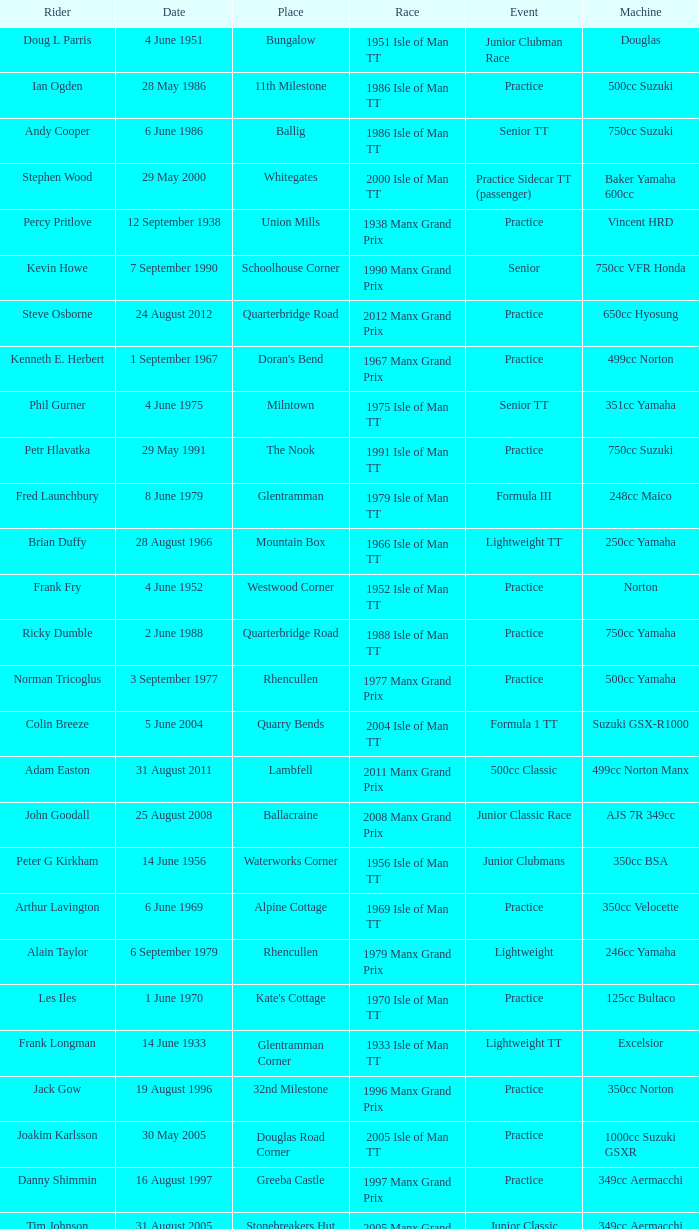What event was Rob Vine riding? Senior TT. 